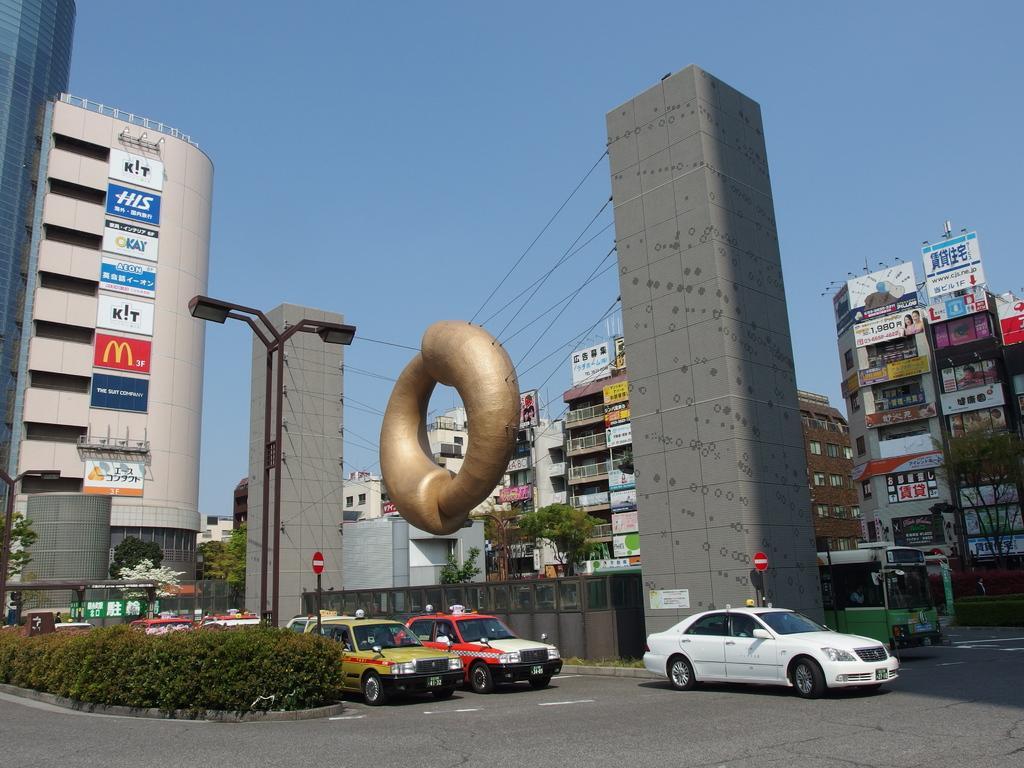In one or two sentences, can you explain what this image depicts? In this image we can see vehicles are moving on the road, we can see shrubs, architecture, light poles, sign boards, tower buildings, trees and the sky in the background. 